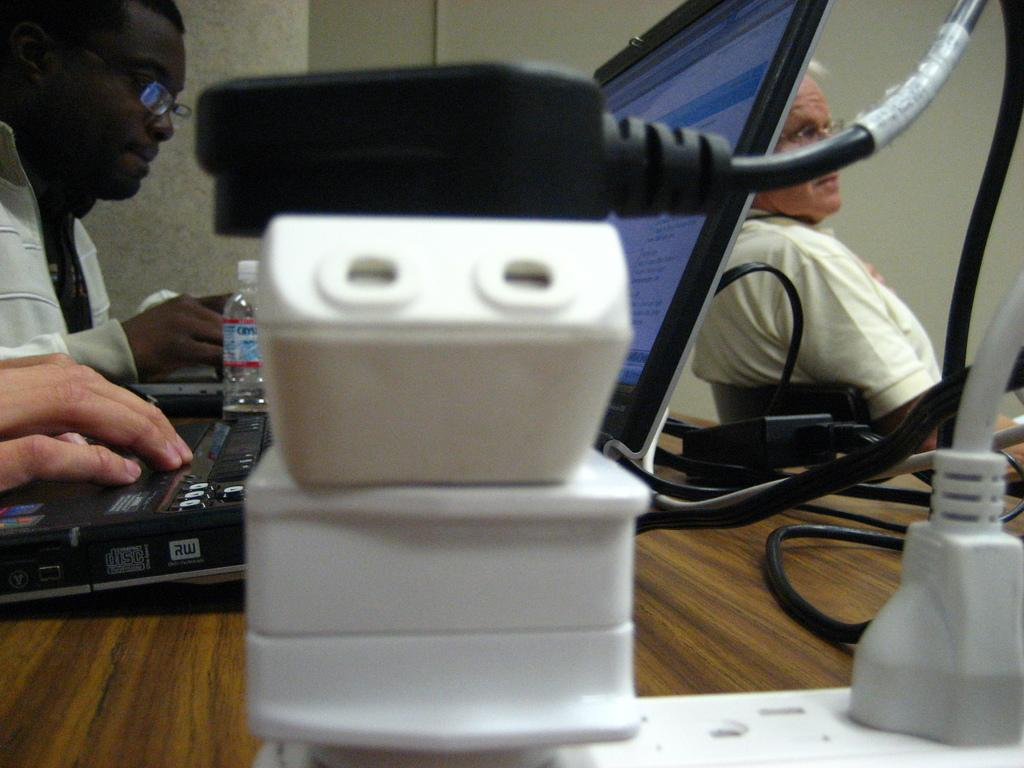What are the two persons in the image doing? The two persons in the image are operating a laptop. What can be seen near the two persons? There is a plug board beside the two persons. Can you describe the person sitting in the right corner of the image? There is another person sitting in the right corner of the image. What type of cheese is being used to balance the laptop in the image? There is no cheese present in the image, and the laptop is not being balanced on any object. 